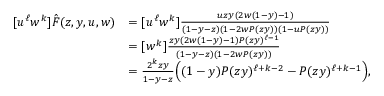Convert formula to latex. <formula><loc_0><loc_0><loc_500><loc_500>\begin{array} { r l } { [ u ^ { \ell } w ^ { k } ] \hat { F } ( z , y , u , w ) } & { = [ u ^ { \ell } w ^ { k } ] \frac { u z y ( 2 w ( 1 - y ) - 1 ) } { ( 1 - y - z ) ( 1 - 2 w P ( z y ) ) ( 1 - u P ( z y ) ) } } \\ & { = [ w ^ { k } ] \frac { z y ( 2 w ( 1 - y ) - 1 ) P ( z y ) ^ { \ell - 1 } } { ( 1 - y - z ) ( 1 - 2 w P ( z y ) ) } } \\ & { = \frac { 2 ^ { k } z y } { 1 - y - z } \left ( ( 1 - y ) P ( z y ) ^ { \ell + k - 2 } - P ( z y ) ^ { \ell + k - 1 } \right ) , } \end{array}</formula> 